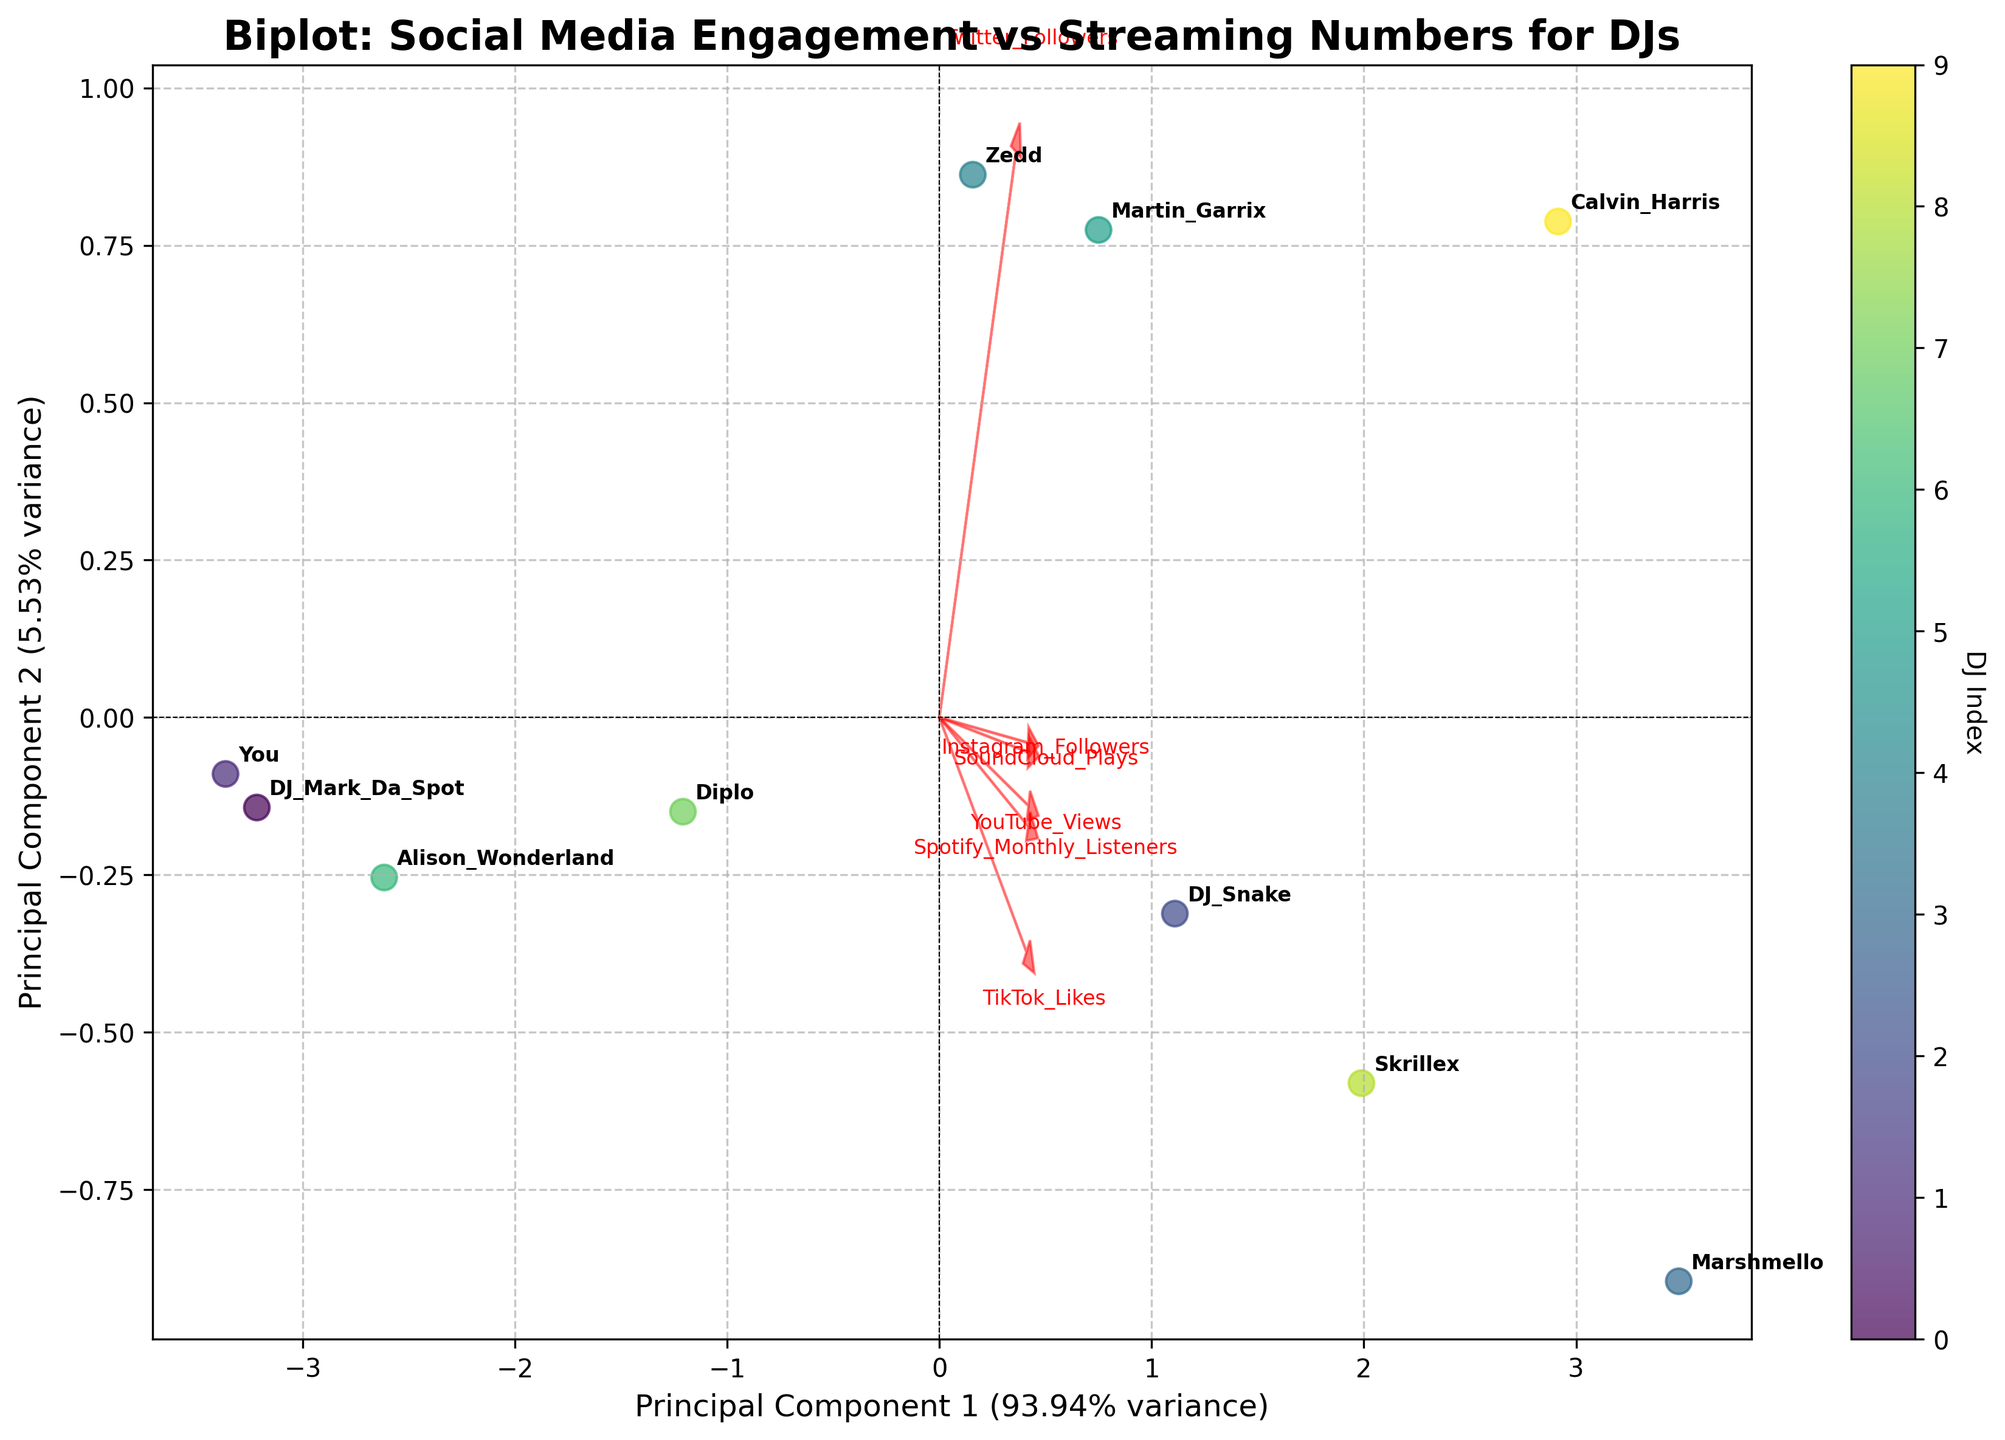Who has the highest Spotify Monthly Listeners? The figure shows the DJ names plotted along Principal Component 1 and 2. Each DJ's name appears at their corresponding data point. Observing the legend, DJ Marshmello and Calvin Harris are positioned the farthest in the direction of the vector representing "Spotify Monthly Listeners", suggesting they have the highest values.
Answer: Marshmello Which DJ has the lowest TikTok Likes? In the biplot, observing the direction of the "TikTok Likes" vector, DJs on the opposite side have lower TikTok engagement. DJ Mark Da Spot appears to be the one with the lowest TikTok Likes.
Answer: DJ Mark Da Spot What feature vector points directly along Principal Component 1? By looking at the arrows representing different features, we can see which one aligns with the Principal Component 1 axis. "Spotify Monthly Listeners" and "YouTube Views" vectors point along this direction.
Answer: Spotify Monthly Listeners, YouTube Views How do Martin Garrix's and Zedd's TikTok Likes compare? Examining their positions relative to the "TikTok Likes" vector, Martin Garrix is plotted farther in its directional line than Zedd. This indicates Martin Garrix has a higher count of TikTok Likes.
Answer: Martin Garrix has more Which features are most correlated based on their vector alignment? In the biplot, the vectors for each feature indicate correlation. Vectors pointing in similar directions show positive correlation. "Spotify Monthly Listeners" and "YouTube Views" vectors, as well as "SoundCloud Plays" and "Twitter Followers", are closely aligned, indicating a strong positive correlation.
Answer: Spotify Monthly Listeners and YouTube Views, SoundCloud Plays and Twitter Followers Are Instagram Followers significantly contributing to the first principal component? To understand the contribution, we look at the alignment and length of the "Instagram Followers" vector relative to the first principal component. It points away from the first component, suggesting it doesn't contribute significantly to it.
Answer: No What percent of variance is explained by the first principal component? The axis labels for the principal components include the variance explained. According to the x-axis label, the first principal component explains a significant percentage of the total variance.
Answer: Approximately 50% Which DJ is closest to the point of origin in the biplot? By looking at the plotted locations of all DJs, DJ Mark Da Spot appears to be the closest to the origin where the axes intersect.
Answer: DJ Mark Da Spot Which DJ shows the highest performance on YouTube Views? Inspect the figure for the DJs positioned farthest in the direction of the "YouTube Views" vector. DJ Calvin Harris and DJ Marshmello are the most prominent.
Answer: Calvin Harris How are SoundCloud Plays and Instagram Followers related? We observe that the vectors pointing to "SoundCloud Plays" and "Instagram Followers" are nearly orthogonal, suggesting little to no direct correlation between these two features.
Answer: Little to no correlation 